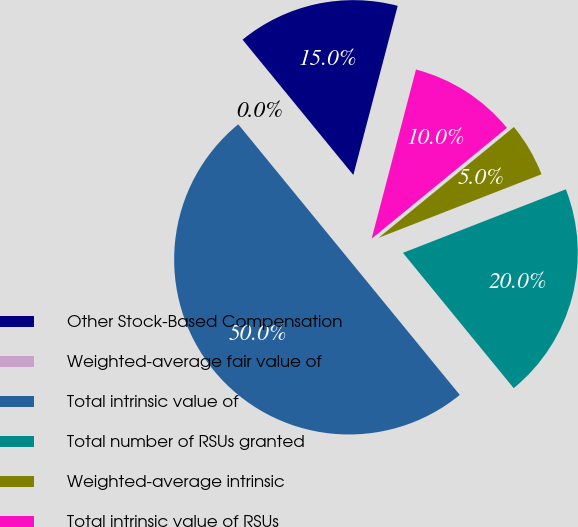<chart> <loc_0><loc_0><loc_500><loc_500><pie_chart><fcel>Other Stock-Based Compensation<fcel>Weighted-average fair value of<fcel>Total intrinsic value of<fcel>Total number of RSUs granted<fcel>Weighted-average intrinsic<fcel>Total intrinsic value of RSUs<nl><fcel>15.0%<fcel>0.0%<fcel>50.0%<fcel>20.0%<fcel>5.0%<fcel>10.0%<nl></chart> 